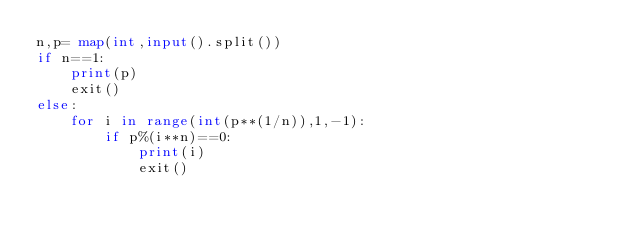<code> <loc_0><loc_0><loc_500><loc_500><_Python_>n,p= map(int,input().split())
if n==1:
    print(p)
    exit()
else:
    for i in range(int(p**(1/n)),1,-1):
        if p%(i**n)==0:
            print(i)
            exit()
</code> 